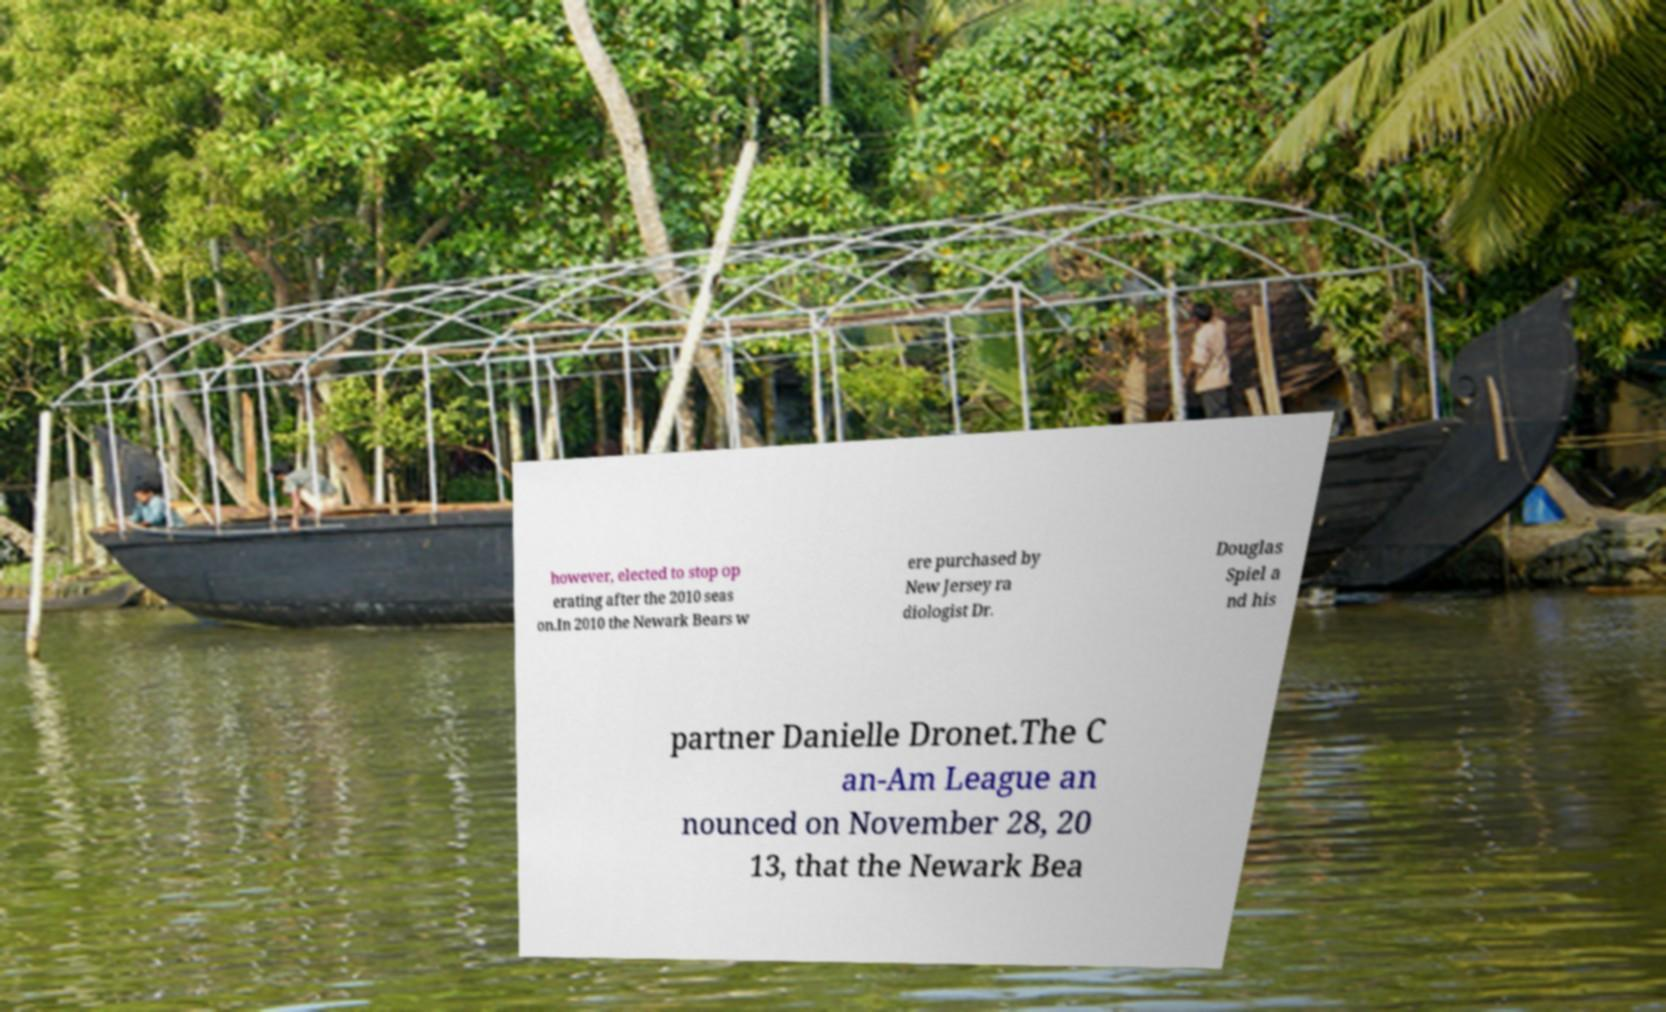Please identify and transcribe the text found in this image. however, elected to stop op erating after the 2010 seas on.In 2010 the Newark Bears w ere purchased by New Jersey ra diologist Dr. Douglas Spiel a nd his partner Danielle Dronet.The C an-Am League an nounced on November 28, 20 13, that the Newark Bea 